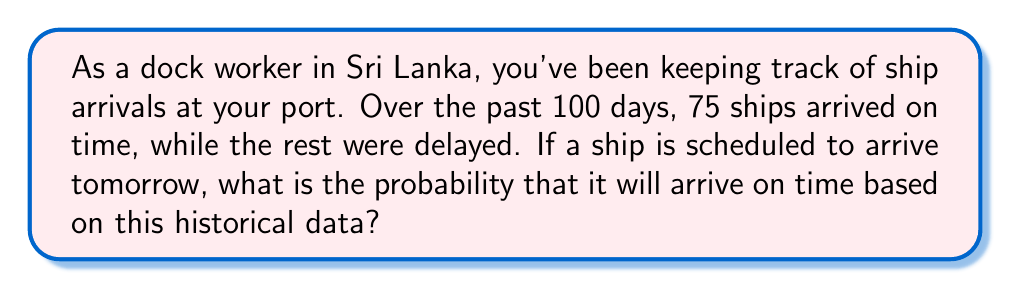Show me your answer to this math problem. To solve this problem, we need to use the concept of relative frequency as an estimate of probability. Here's a step-by-step explanation:

1. Identify the total number of observations:
   Total observations = 100 days

2. Identify the number of favorable outcomes:
   Ships arriving on time = 75

3. Calculate the probability using the formula:

   $$P(\text{ship arriving on time}) = \frac{\text{number of ships arriving on time}}{\text{total number of observations}}$$

4. Substitute the values:

   $$P(\text{ship arriving on time}) = \frac{75}{100}$$

5. Simplify the fraction:

   $$P(\text{ship arriving on time}) = 0.75$$

This means that based on the historical data, there is a 75% chance (or 0.75 probability) that the ship scheduled to arrive tomorrow will be on time.
Answer: The probability that the ship will arrive on time is 0.75 or 75%. 